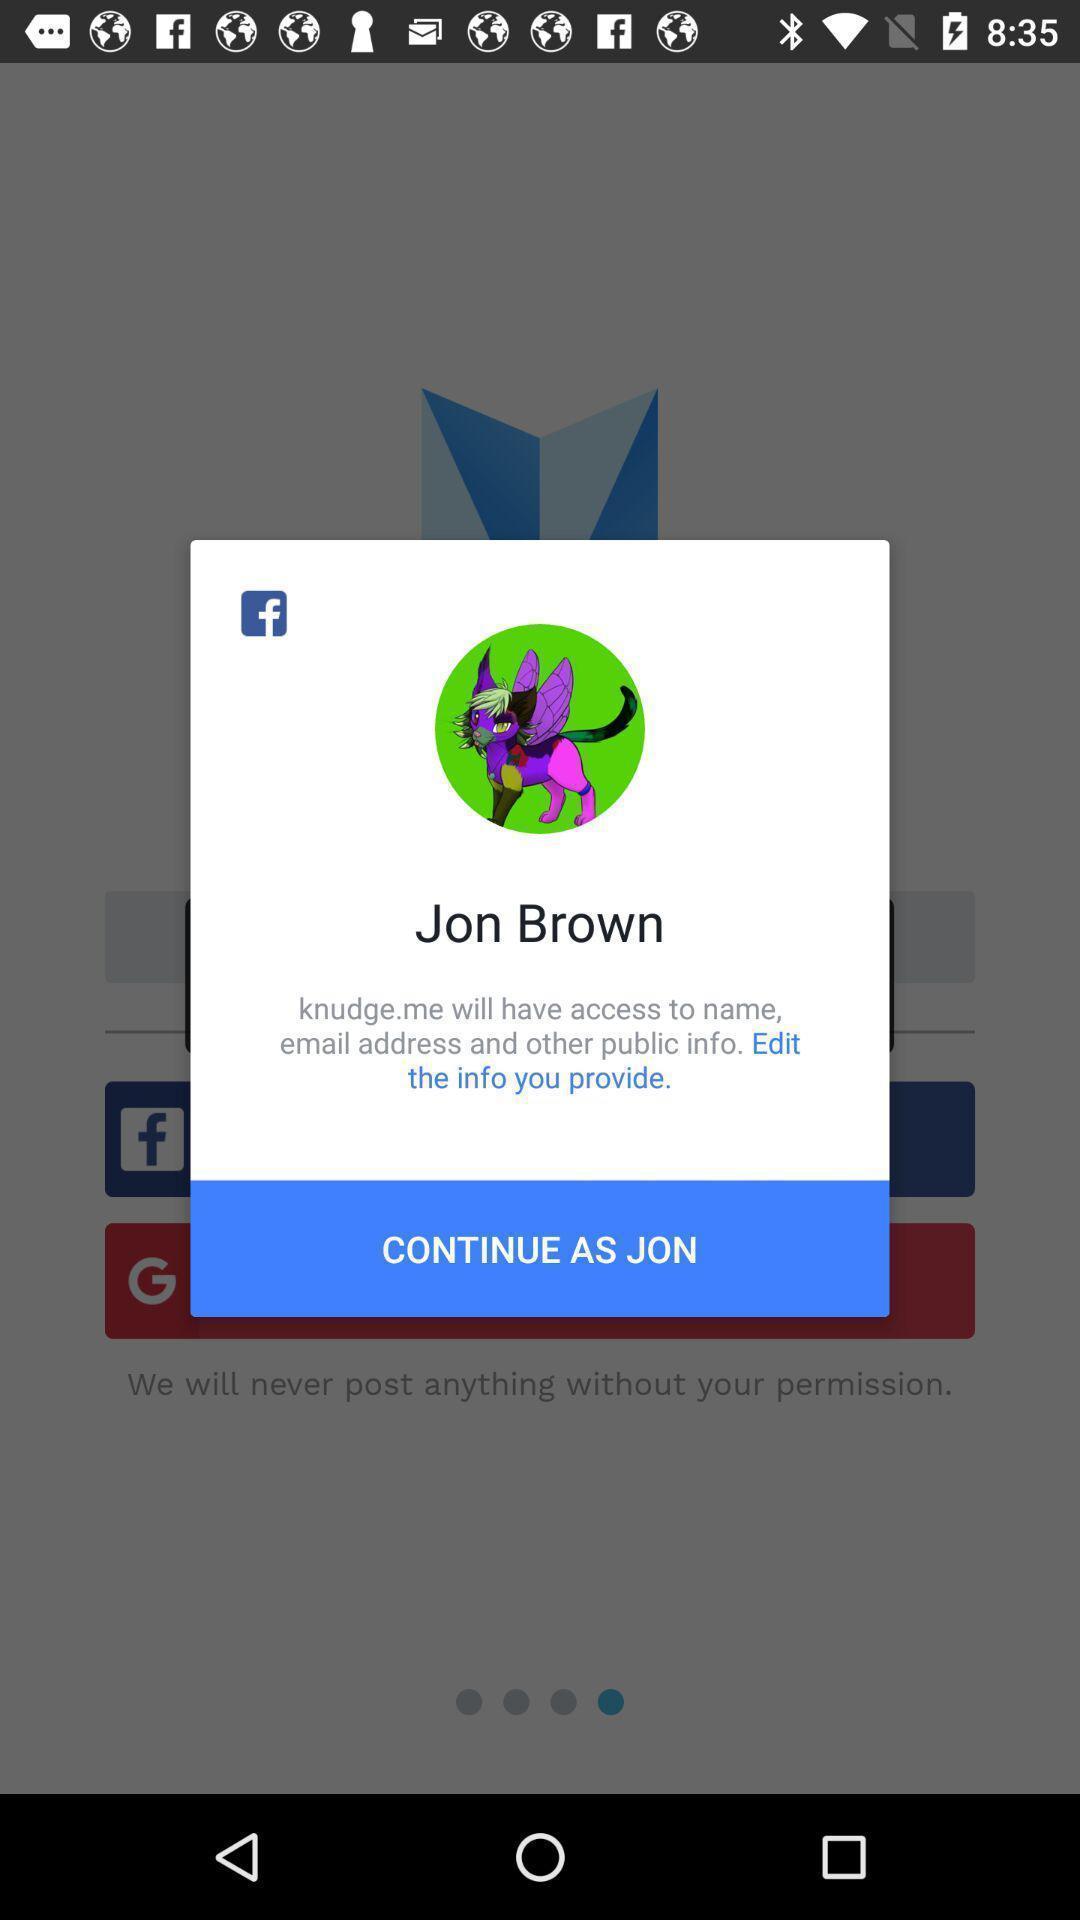Describe the key features of this screenshot. Pop-up shows to continue with social app. 